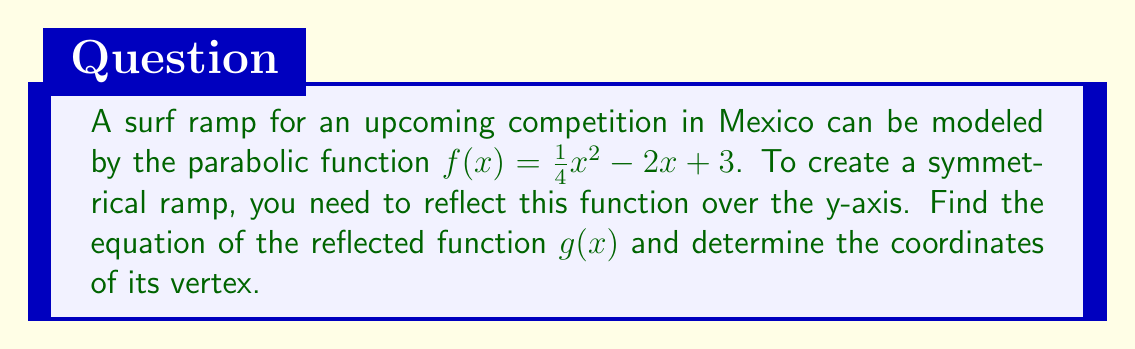Help me with this question. 1) To reflect a function over the y-axis, we replace every x with -x in the original function. So, $f(x)=\frac{1}{4}x^2-2x+3$ becomes $g(x)=\frac{1}{4}(-x)^2-2(-x)+3$.

2) Simplify the reflected function:
   $g(x)=\frac{1}{4}x^2+2x+3$

3) To find the vertex of $g(x)$, we use the general form of a quadratic function: $g(x)=a(x-h)^2+k$, where $(h,k)$ is the vertex.

4) First, identify $a$, which is the coefficient of $x^2$:
   $a=\frac{1}{4}$

5) Use the formula $h=-\frac{b}{2a}$, where $b$ is the coefficient of $x$:
   $h=-\frac{2}{2(\frac{1}{4})}=-4$

6) Substitute $x=h=-4$ into $g(x)$ to find $k$:
   $k=g(-4)=\frac{1}{4}(-4)^2+2(-4)+3=4-8+3=-1$

7) Therefore, the vertex of $g(x)$ is $(-4,-1)$.
Answer: $g(x)=\frac{1}{4}x^2+2x+3$; vertex $(-4,-1)$ 